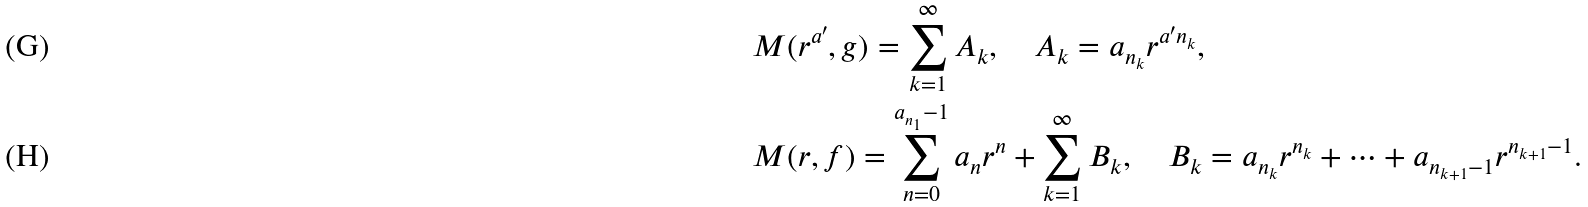Convert formula to latex. <formula><loc_0><loc_0><loc_500><loc_500>& M ( r ^ { a ^ { \prime } } , g ) = \sum _ { k = 1 } ^ { \infty } A _ { k } , \quad A _ { k } = a _ { n _ { k } } r ^ { a ^ { \prime } n _ { k } } , \\ & M ( r , f ) = \sum _ { n = 0 } ^ { a _ { n _ { 1 } } - 1 } a _ { n } r ^ { n } + \sum _ { k = 1 } ^ { \infty } B _ { k } , \quad B _ { k } = a _ { n _ { k } } r ^ { n _ { k } } + \cdots + a _ { n _ { k + 1 } - 1 } r ^ { n _ { k + 1 } - 1 } .</formula> 